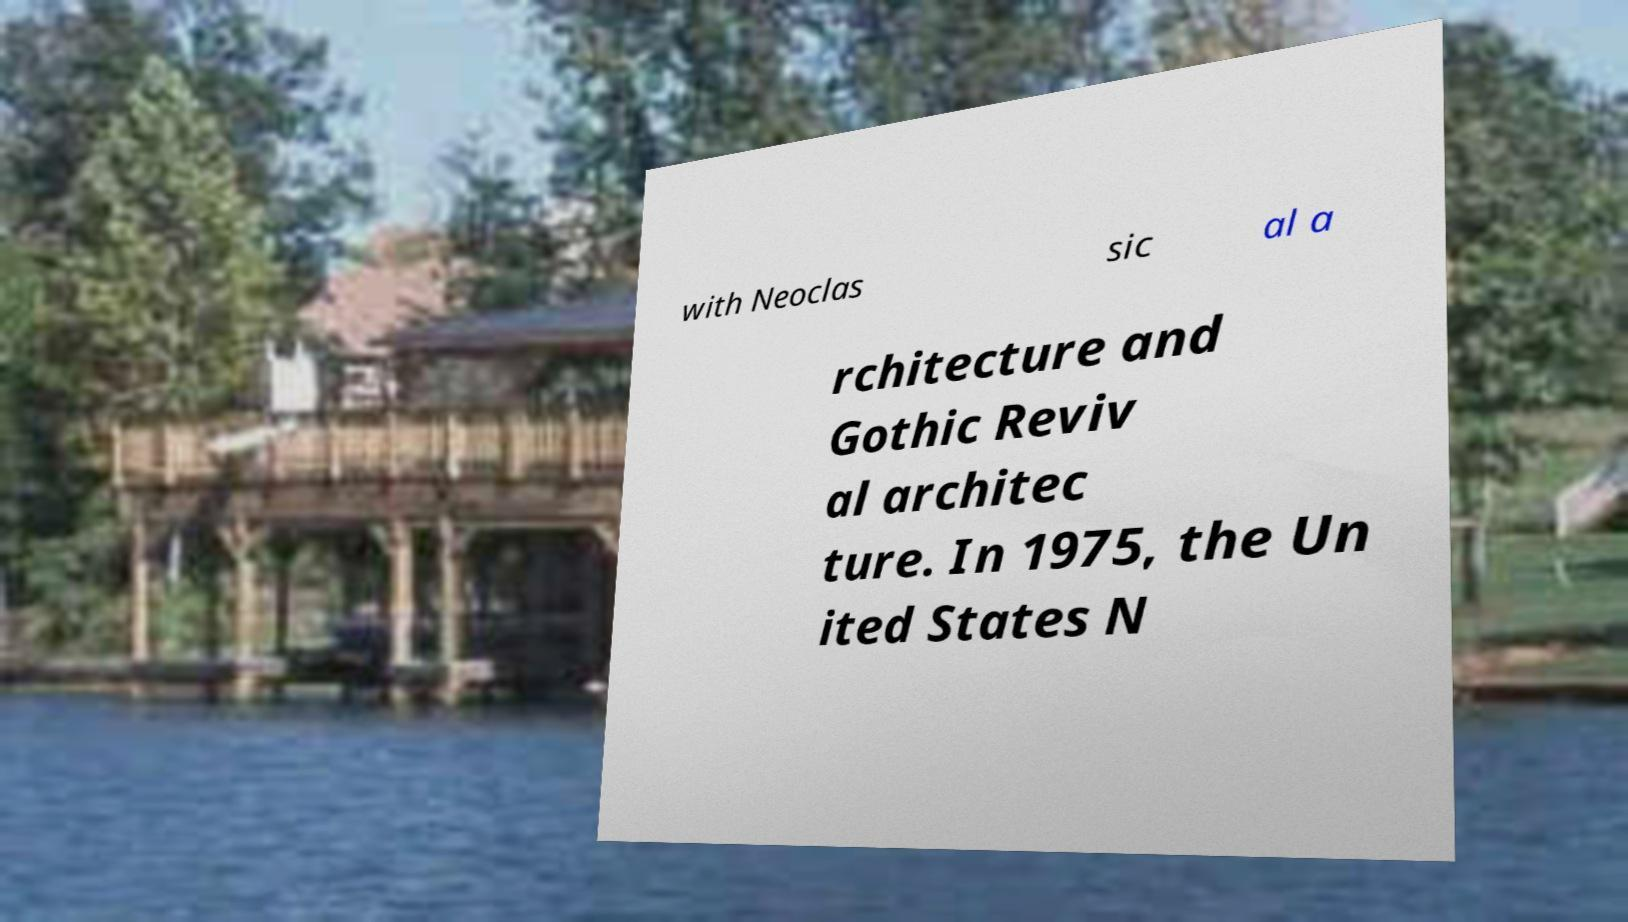What messages or text are displayed in this image? I need them in a readable, typed format. with Neoclas sic al a rchitecture and Gothic Reviv al architec ture. In 1975, the Un ited States N 